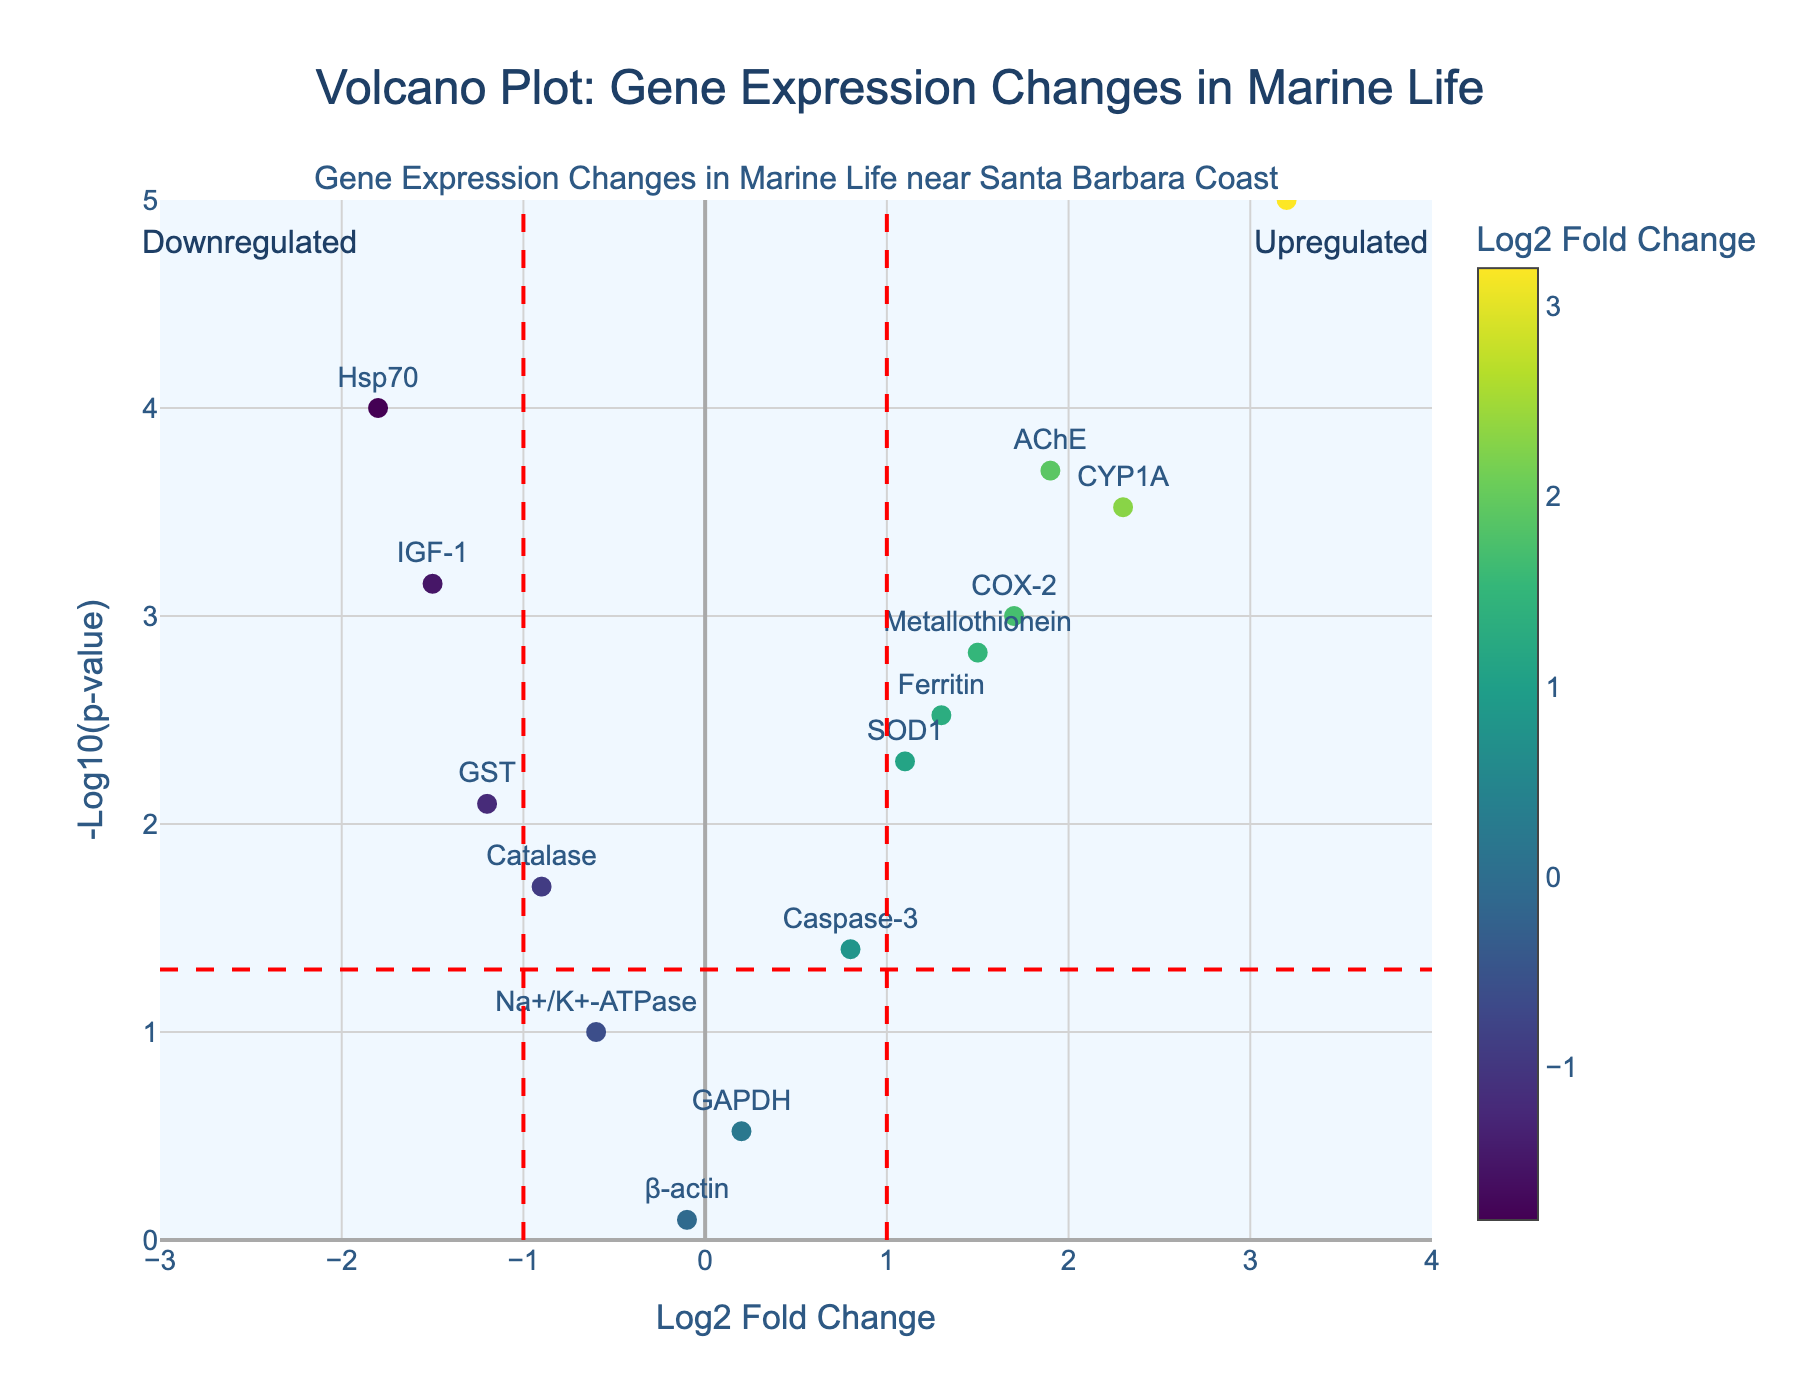What is the gene with the highest log2 fold change? To find the gene with the highest log2 fold change, look for the data point farthest to the right on the x-axis. The gene "Vitellogenin" has the highest log2 fold change of 3.2.
Answer: Vitellogenin Which gene shows the most significant change based on p-value? The most significant change is determined by the gene with the highest -log10(p-value), which appears highest on the y-axis. The gene "Vitellogenin" has the most significant change with a -log10(p-value) of 5.
Answer: Vitellogenin How many genes are downregulated with a log2 fold change less than -1? For downregulated genes, look for those data points with a log2 fold change less than -1 on the x-axis. There are 3 genes: "Hsp70", "GST", and "IGF-1".
Answer: 3 Which genes are upregulated with significant p-values (less than 0.05) and a fold change greater than 1? To find these genes, locate data points to the right of the vertical line at log2 fold change = 1 and above the horizontal line at -log10(p-value) = 1.3 (p-value of 0.05). The genes "CYP1A", "Vitellogenin", and “AChE” meet these criteria.
Answer: CYP1A, Vitellogenin, AChE Compare the log2 fold changes of “SOD1” and “CYP1A”. Which one has a higher value? "SOD1" has a log2 fold change of 1.1, while "CYP1A" has a log2 fold change of 2.3. Compare these values to determine that "CYP1A" has a higher log2 fold change.
Answer: CYP1A What is the log2 fold change of the gene "Catalase"? To find this value, look for "Catalase" and read its corresponding x-axis value, which is -0.9.
Answer: -0.9 Calculate the average log2 fold change of "Metallothionein" and "Caspase-3". Add the log2 fold changes of "Metallothionein" (1.5) and "Caspase-3" (0.8) and divide by 2. The calculation is (1.5 + 0.8) / 2 = 1.15.
Answer: 1.15 Which gene has a higher -log10(p-value), "COX-2" or "Ferritin"? Compare the y-axis values, where "COX-2" has -log10(p-value) of 3 and "Ferritin" has -log10(p-value) of 2.48. "COX-2" has a higher -log10(p-value).
Answer: COX-2 